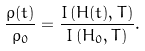Convert formula to latex. <formula><loc_0><loc_0><loc_500><loc_500>\frac { \rho ( t ) } { \rho _ { 0 } } = \frac { I \left ( H ( t ) , T \right ) } { I \left ( H _ { 0 } , T \right ) } .</formula> 